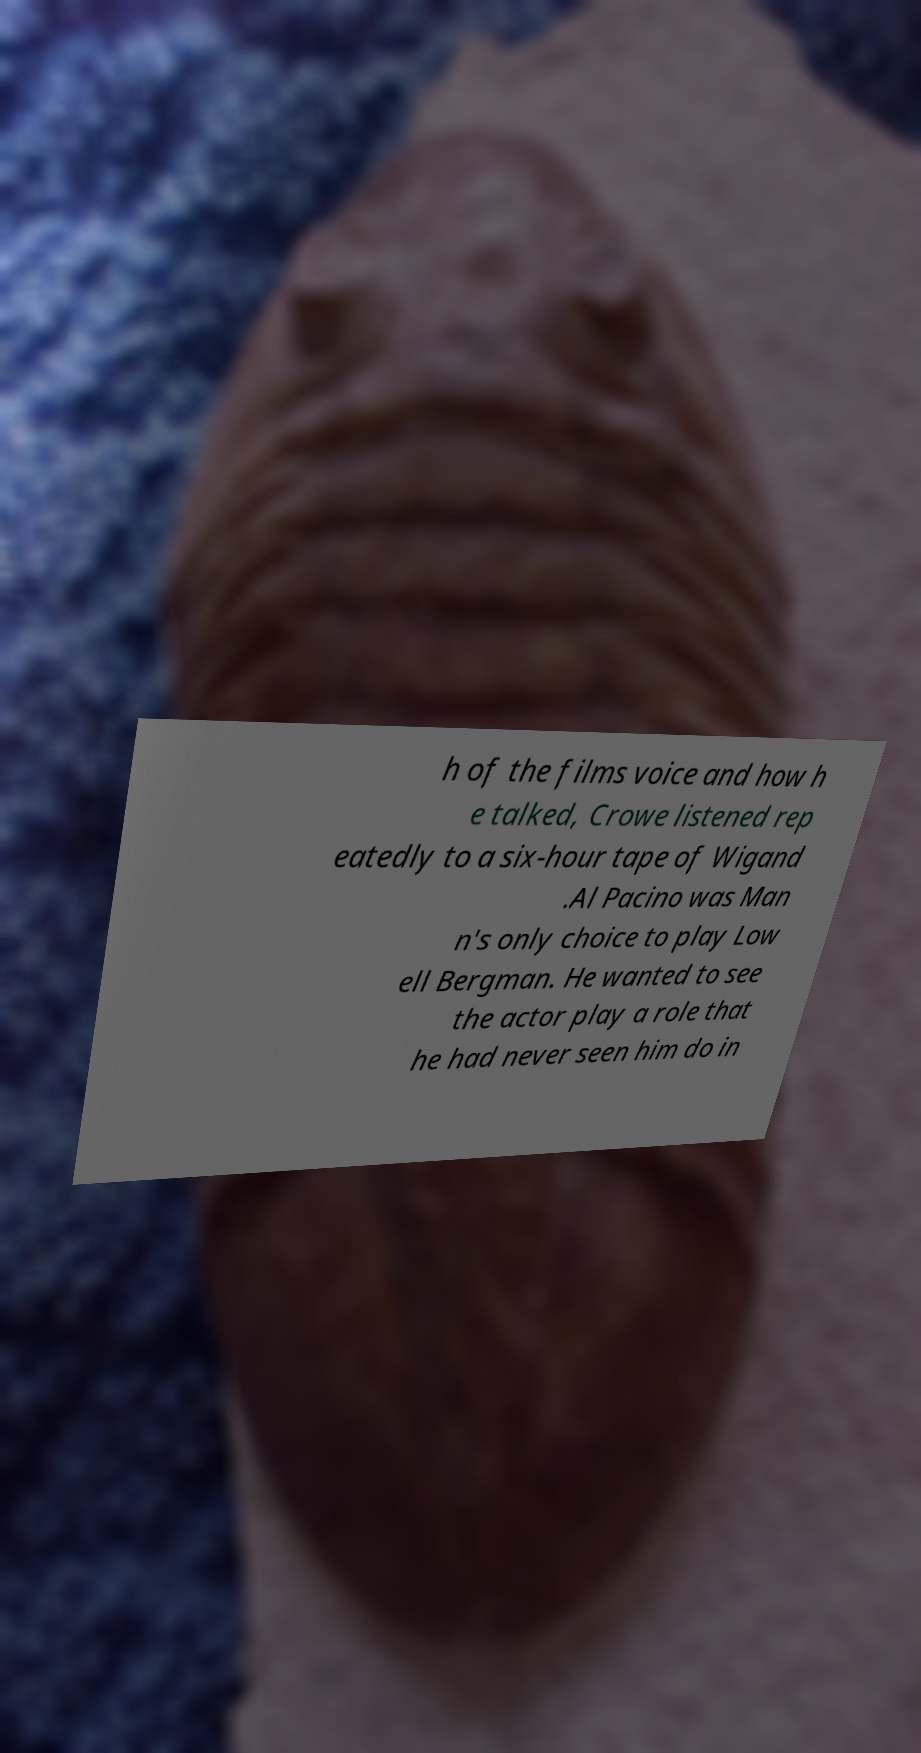For documentation purposes, I need the text within this image transcribed. Could you provide that? h of the films voice and how h e talked, Crowe listened rep eatedly to a six-hour tape of Wigand .Al Pacino was Man n's only choice to play Low ell Bergman. He wanted to see the actor play a role that he had never seen him do in 